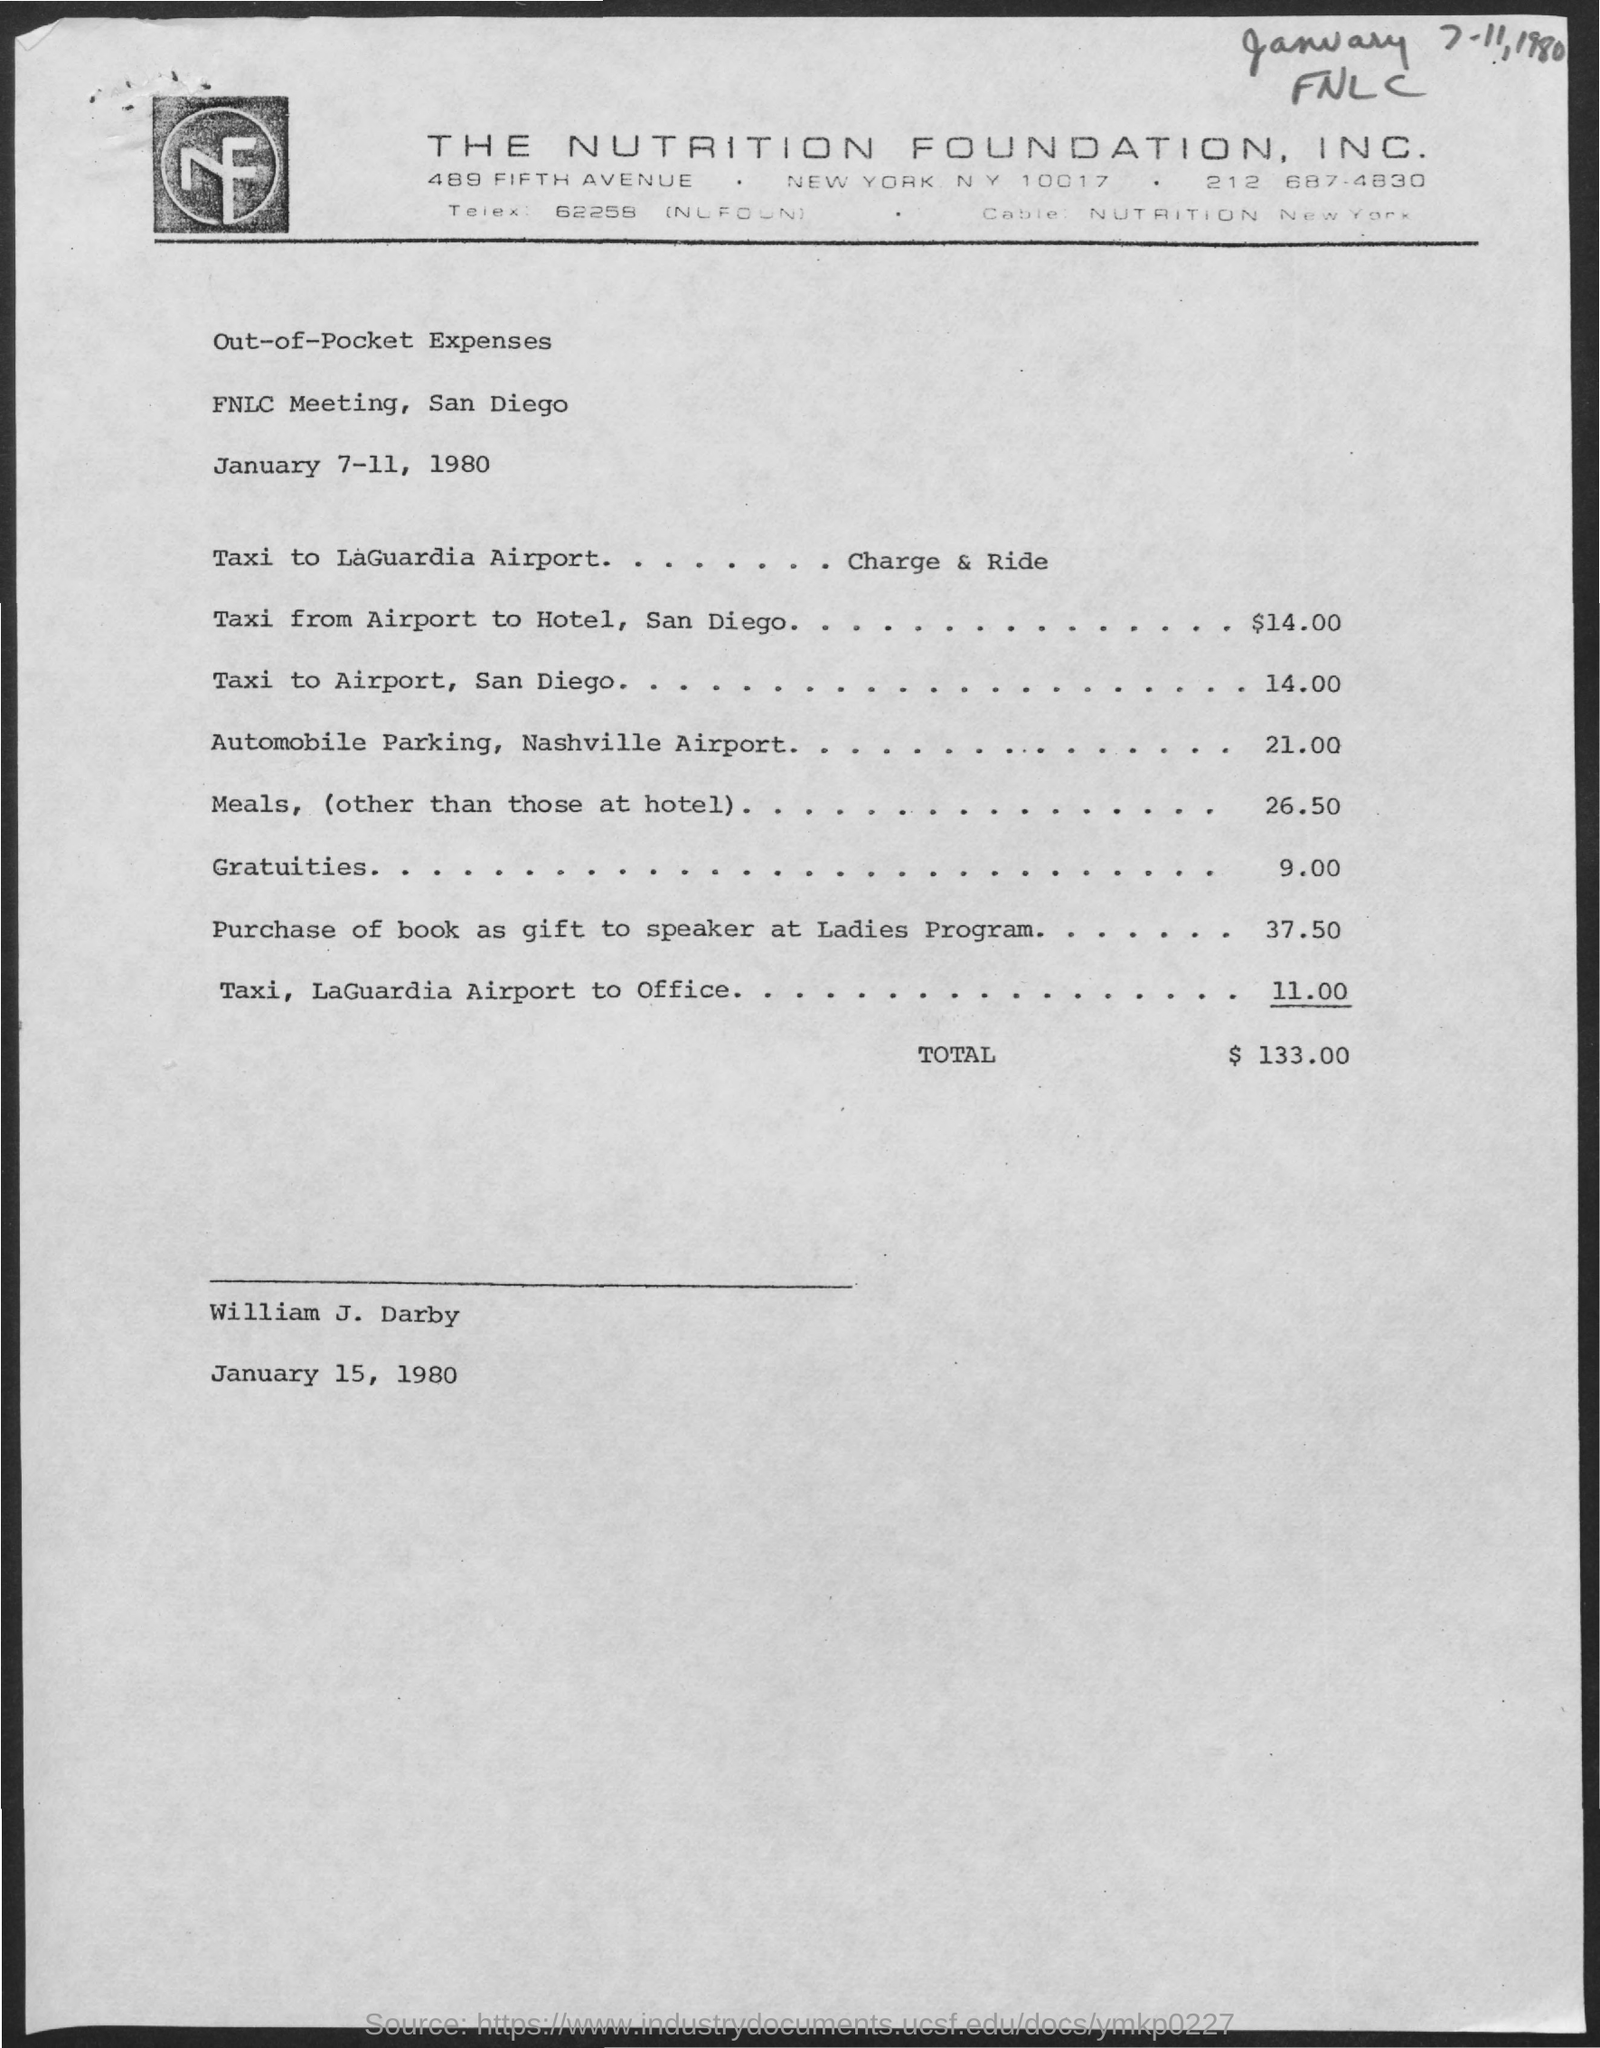On which dates the fnlc meeting are scheduled ?
Offer a terse response. January 7-11 , 1980. What are the expenses for taxi from airport to hotel, san diego ?
Keep it short and to the point. $ 14.00. What are the expenses for automobile parking, nashville airport ?
Ensure brevity in your answer.  21.00. What are the expenses for meals (other than those at hotel )?
Provide a succinct answer. 26.50. 